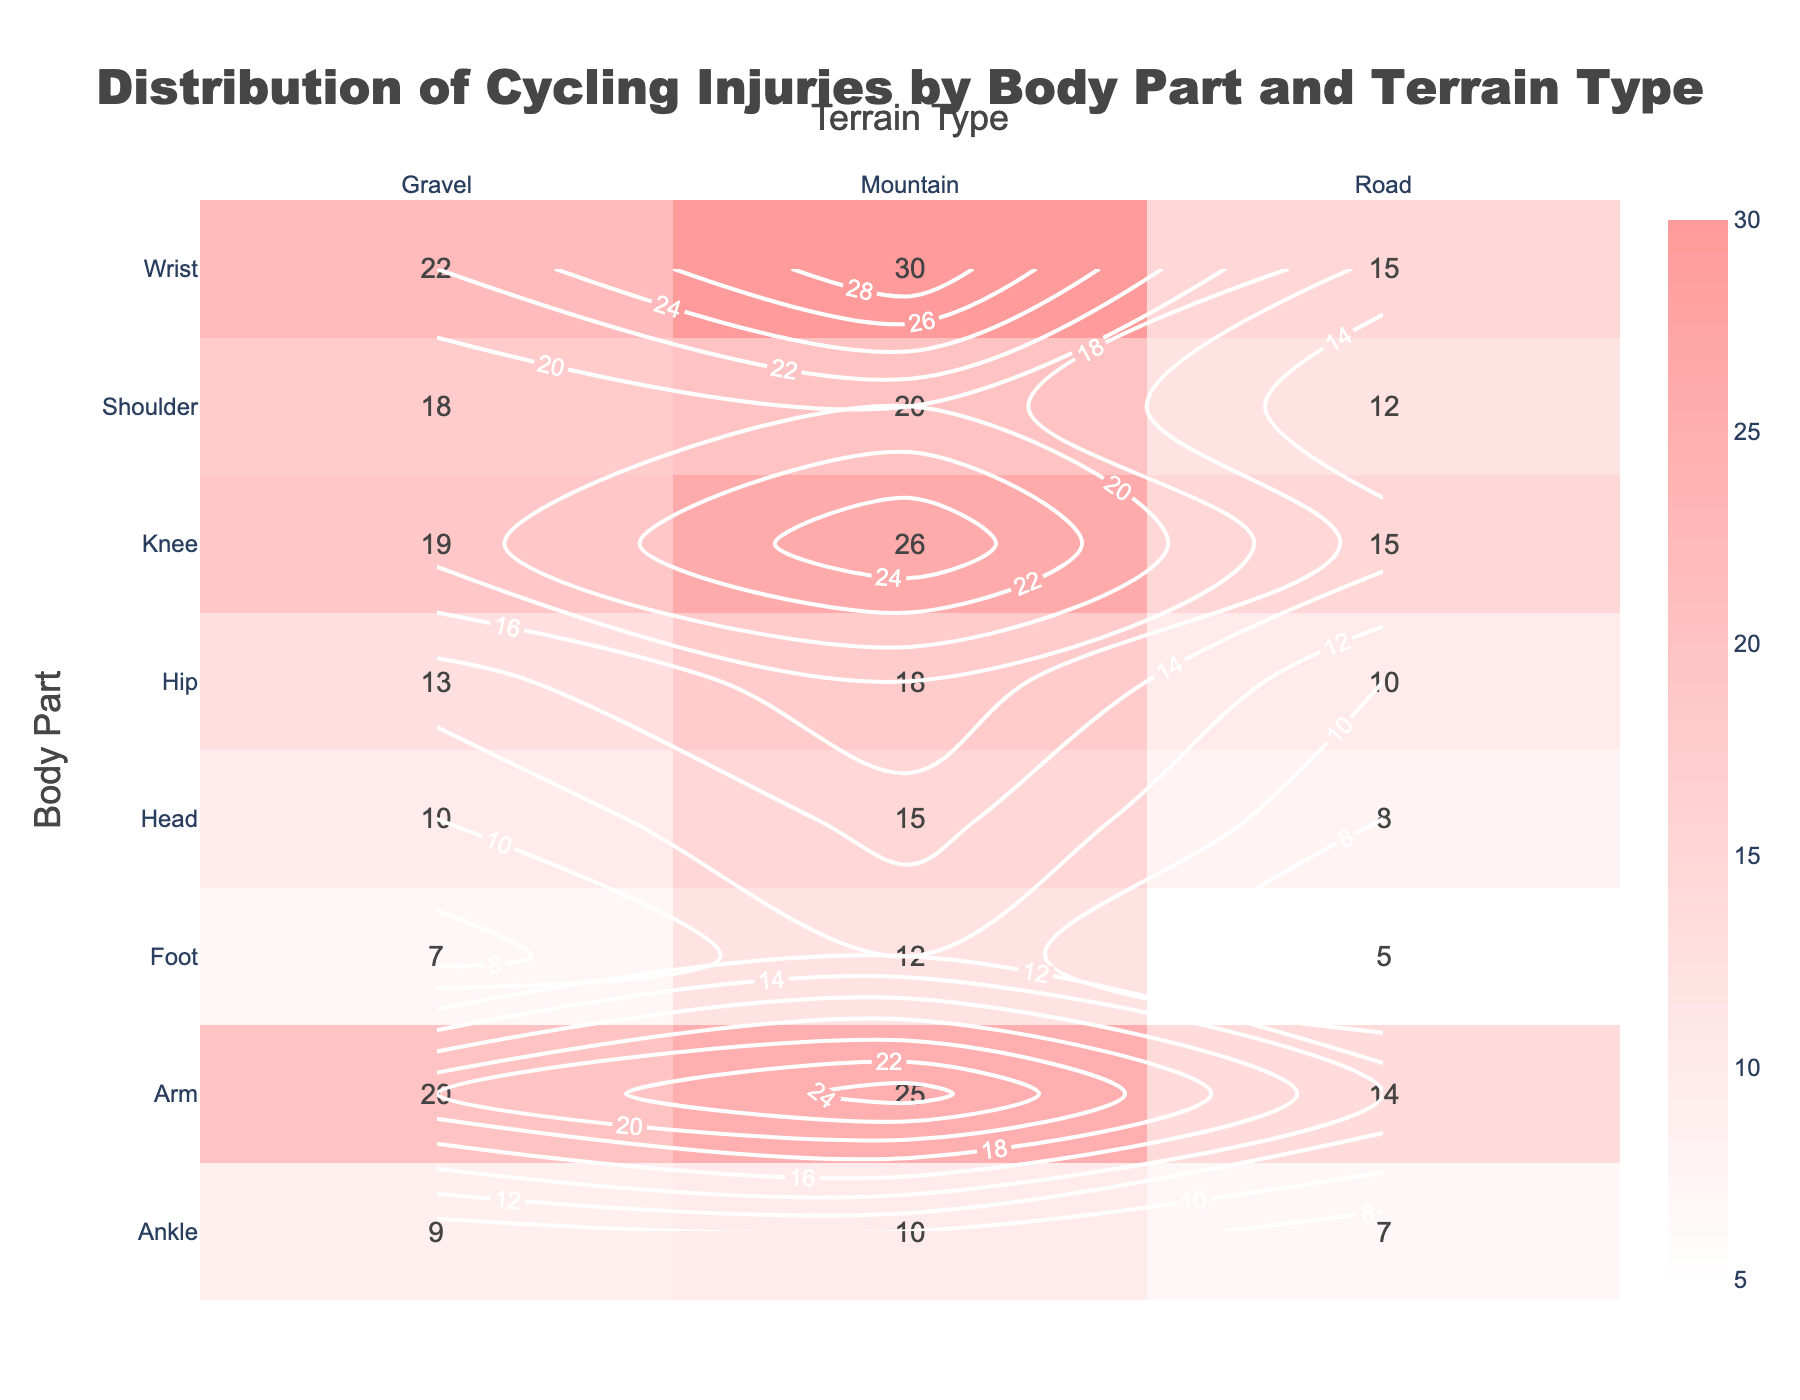Which terrain type has the highest total injury count for the wrist? By observing the plot, we can see the injury counts for the wrist across all terrain types. Summing them up for Mountain (30), Road (15), and Gravel (22), the highest count is for Mountain with 30 injuries.
Answer: Mountain What is the total number of injuries for the hip across all terrain types? Observing the plot, we see the injury count for the hip on Mountain (18), Road (10), and Gravel (13). Adding these numbers gives 18 + 10 + 13 = 41.
Answer: 41 Which body part has the highest injury count on gravel terrain? On the plot, look at the column for Gravel terrain, and find the maximum count. The highest count on Gravel is for Wrist with 22 injuries.
Answer: Wrist Are the injury counts higher on mountain or road terrains for knees? Comparing the counts for knees, Mountain has 26 injuries and Road has 15 injuries. Mountain has higher injury counts.
Answer: Mountain What is the average number of injuries for the shoulder across all terrain types? From the plot, the counts for the shoulder are Mountain (20), Road (12), and Gravel (18). The average is calculated as (20 + 12 + 18) / 3 = 16.67.
Answer: 16.67 What is the difference in injury counts between the arm and ankle on mountain terrain? From the plot, the injury count for arm on Mountain is 25 and for ankle is 10. The difference is 25 - 10 = 15.
Answer: 15 Which body part has the lowest injury count on each terrain type? Observing the lowest count in each terrain type, on Mountain it is Ankle with 10 injuries, on Road it is Foot with 5 injuries, and on Gravel it is Foot with 7 injuries.
Answer: Mountain-Ankle, Road-Foot, Gravel-Foot Which body part has the highest injury count overall? By adding up the injury counts for all terrain types and comparing them, the wrist has the highest total injuries adding up to 67 (30 mountain + 15 road + 22 gravel).
Answer: Wrist How does the injury count for hips on road terrain compare to that of shoulders on road terrain? Observing the counts on road terrain from the plot, hips have 10, and shoulders have 12 injuries. Shoulders have higher injury counts on road terrain.
Answer: Shoulders Is the number of injuries on gravel terrain generally higher or lower than on mountain terrain? By comparing the injury counts for each body part on gravel and mountain terrain from the plot, we can see that mountain terrain generally has higher counts for each body part compared to gravel.
Answer: Lower 